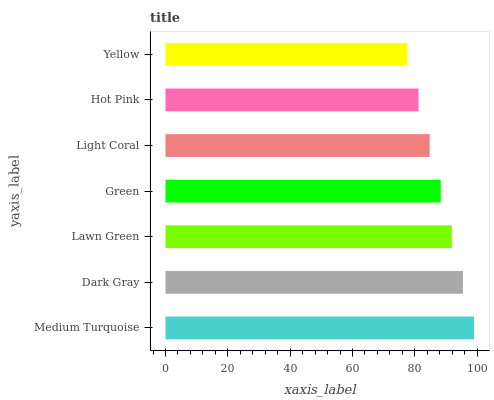Is Yellow the minimum?
Answer yes or no. Yes. Is Medium Turquoise the maximum?
Answer yes or no. Yes. Is Dark Gray the minimum?
Answer yes or no. No. Is Dark Gray the maximum?
Answer yes or no. No. Is Medium Turquoise greater than Dark Gray?
Answer yes or no. Yes. Is Dark Gray less than Medium Turquoise?
Answer yes or no. Yes. Is Dark Gray greater than Medium Turquoise?
Answer yes or no. No. Is Medium Turquoise less than Dark Gray?
Answer yes or no. No. Is Green the high median?
Answer yes or no. Yes. Is Green the low median?
Answer yes or no. Yes. Is Hot Pink the high median?
Answer yes or no. No. Is Dark Gray the low median?
Answer yes or no. No. 